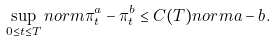Convert formula to latex. <formula><loc_0><loc_0><loc_500><loc_500>\sup _ { 0 \leq t \leq T } \sl n o r m { \pi ^ { a } _ { t } - \pi ^ { b } _ { t } } \leq C ( T ) \sl n o r m { a - b } .</formula> 